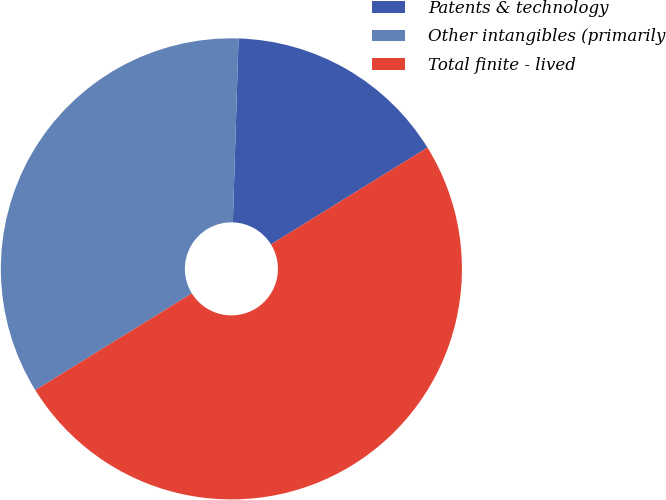<chart> <loc_0><loc_0><loc_500><loc_500><pie_chart><fcel>Patents & technology<fcel>Other intangibles (primarily<fcel>Total finite - lived<nl><fcel>15.69%<fcel>34.31%<fcel>50.0%<nl></chart> 